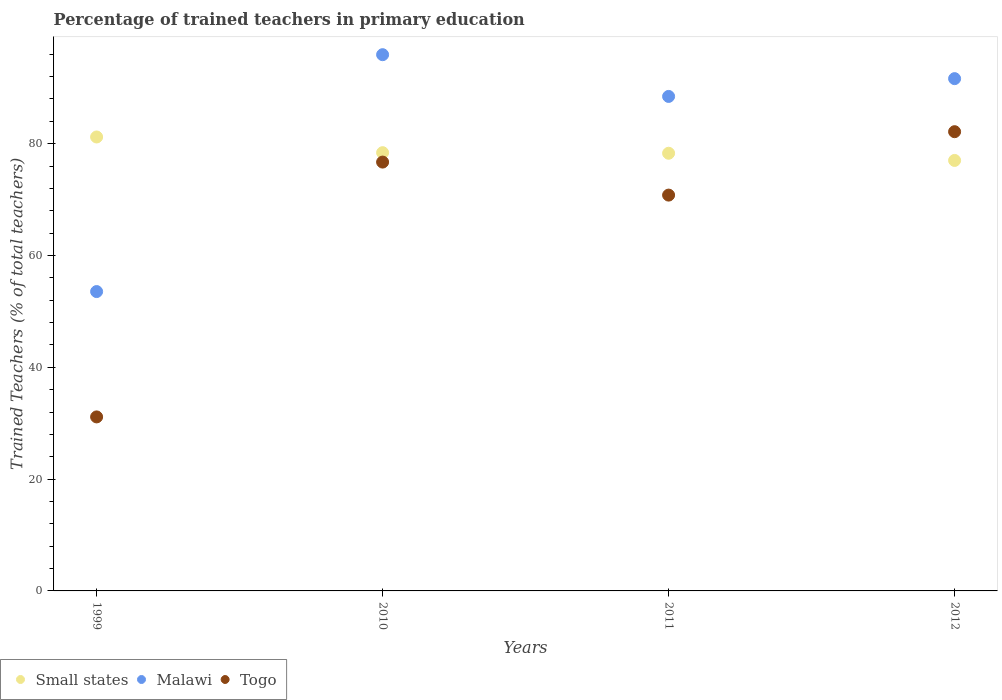Is the number of dotlines equal to the number of legend labels?
Offer a terse response. Yes. What is the percentage of trained teachers in Malawi in 2012?
Ensure brevity in your answer.  91.63. Across all years, what is the maximum percentage of trained teachers in Malawi?
Keep it short and to the point. 95.91. Across all years, what is the minimum percentage of trained teachers in Togo?
Your answer should be compact. 31.12. In which year was the percentage of trained teachers in Togo minimum?
Offer a terse response. 1999. What is the total percentage of trained teachers in Togo in the graph?
Offer a terse response. 260.76. What is the difference between the percentage of trained teachers in Malawi in 2011 and that in 2012?
Keep it short and to the point. -3.18. What is the difference between the percentage of trained teachers in Small states in 1999 and the percentage of trained teachers in Malawi in 2010?
Give a very brief answer. -14.72. What is the average percentage of trained teachers in Malawi per year?
Offer a terse response. 82.38. In the year 2012, what is the difference between the percentage of trained teachers in Small states and percentage of trained teachers in Togo?
Offer a terse response. -5.14. What is the ratio of the percentage of trained teachers in Small states in 1999 to that in 2010?
Your response must be concise. 1.04. What is the difference between the highest and the second highest percentage of trained teachers in Togo?
Offer a terse response. 5.44. What is the difference between the highest and the lowest percentage of trained teachers in Small states?
Provide a succinct answer. 4.2. In how many years, is the percentage of trained teachers in Small states greater than the average percentage of trained teachers in Small states taken over all years?
Make the answer very short. 1. Is the sum of the percentage of trained teachers in Malawi in 2010 and 2011 greater than the maximum percentage of trained teachers in Togo across all years?
Make the answer very short. Yes. Does the percentage of trained teachers in Togo monotonically increase over the years?
Offer a terse response. No. Is the percentage of trained teachers in Togo strictly greater than the percentage of trained teachers in Small states over the years?
Keep it short and to the point. No. How many years are there in the graph?
Offer a very short reply. 4. Does the graph contain any zero values?
Keep it short and to the point. No. How many legend labels are there?
Your answer should be very brief. 3. How are the legend labels stacked?
Keep it short and to the point. Horizontal. What is the title of the graph?
Ensure brevity in your answer.  Percentage of trained teachers in primary education. What is the label or title of the X-axis?
Keep it short and to the point. Years. What is the label or title of the Y-axis?
Your response must be concise. Trained Teachers (% of total teachers). What is the Trained Teachers (% of total teachers) in Small states in 1999?
Your answer should be compact. 81.19. What is the Trained Teachers (% of total teachers) in Malawi in 1999?
Ensure brevity in your answer.  53.54. What is the Trained Teachers (% of total teachers) of Togo in 1999?
Offer a very short reply. 31.12. What is the Trained Teachers (% of total teachers) in Small states in 2010?
Keep it short and to the point. 78.39. What is the Trained Teachers (% of total teachers) of Malawi in 2010?
Offer a terse response. 95.91. What is the Trained Teachers (% of total teachers) in Togo in 2010?
Make the answer very short. 76.7. What is the Trained Teachers (% of total teachers) of Small states in 2011?
Keep it short and to the point. 78.28. What is the Trained Teachers (% of total teachers) in Malawi in 2011?
Offer a very short reply. 88.45. What is the Trained Teachers (% of total teachers) of Togo in 2011?
Ensure brevity in your answer.  70.8. What is the Trained Teachers (% of total teachers) of Small states in 2012?
Offer a terse response. 77. What is the Trained Teachers (% of total teachers) in Malawi in 2012?
Provide a succinct answer. 91.63. What is the Trained Teachers (% of total teachers) of Togo in 2012?
Keep it short and to the point. 82.14. Across all years, what is the maximum Trained Teachers (% of total teachers) in Small states?
Your answer should be very brief. 81.19. Across all years, what is the maximum Trained Teachers (% of total teachers) in Malawi?
Make the answer very short. 95.91. Across all years, what is the maximum Trained Teachers (% of total teachers) of Togo?
Offer a very short reply. 82.14. Across all years, what is the minimum Trained Teachers (% of total teachers) of Small states?
Offer a very short reply. 77. Across all years, what is the minimum Trained Teachers (% of total teachers) in Malawi?
Provide a succinct answer. 53.54. Across all years, what is the minimum Trained Teachers (% of total teachers) of Togo?
Provide a short and direct response. 31.12. What is the total Trained Teachers (% of total teachers) in Small states in the graph?
Your answer should be compact. 314.86. What is the total Trained Teachers (% of total teachers) in Malawi in the graph?
Make the answer very short. 329.53. What is the total Trained Teachers (% of total teachers) in Togo in the graph?
Keep it short and to the point. 260.76. What is the difference between the Trained Teachers (% of total teachers) of Small states in 1999 and that in 2010?
Keep it short and to the point. 2.81. What is the difference between the Trained Teachers (% of total teachers) of Malawi in 1999 and that in 2010?
Keep it short and to the point. -42.37. What is the difference between the Trained Teachers (% of total teachers) of Togo in 1999 and that in 2010?
Your answer should be very brief. -45.58. What is the difference between the Trained Teachers (% of total teachers) in Small states in 1999 and that in 2011?
Provide a short and direct response. 2.91. What is the difference between the Trained Teachers (% of total teachers) of Malawi in 1999 and that in 2011?
Give a very brief answer. -34.9. What is the difference between the Trained Teachers (% of total teachers) of Togo in 1999 and that in 2011?
Make the answer very short. -39.67. What is the difference between the Trained Teachers (% of total teachers) in Small states in 1999 and that in 2012?
Keep it short and to the point. 4.2. What is the difference between the Trained Teachers (% of total teachers) of Malawi in 1999 and that in 2012?
Your response must be concise. -38.08. What is the difference between the Trained Teachers (% of total teachers) of Togo in 1999 and that in 2012?
Ensure brevity in your answer.  -51.01. What is the difference between the Trained Teachers (% of total teachers) of Small states in 2010 and that in 2011?
Your answer should be compact. 0.1. What is the difference between the Trained Teachers (% of total teachers) of Malawi in 2010 and that in 2011?
Ensure brevity in your answer.  7.47. What is the difference between the Trained Teachers (% of total teachers) in Togo in 2010 and that in 2011?
Provide a short and direct response. 5.91. What is the difference between the Trained Teachers (% of total teachers) of Small states in 2010 and that in 2012?
Make the answer very short. 1.39. What is the difference between the Trained Teachers (% of total teachers) in Malawi in 2010 and that in 2012?
Keep it short and to the point. 4.28. What is the difference between the Trained Teachers (% of total teachers) in Togo in 2010 and that in 2012?
Provide a short and direct response. -5.44. What is the difference between the Trained Teachers (% of total teachers) of Small states in 2011 and that in 2012?
Keep it short and to the point. 1.29. What is the difference between the Trained Teachers (% of total teachers) of Malawi in 2011 and that in 2012?
Ensure brevity in your answer.  -3.18. What is the difference between the Trained Teachers (% of total teachers) in Togo in 2011 and that in 2012?
Your answer should be very brief. -11.34. What is the difference between the Trained Teachers (% of total teachers) in Small states in 1999 and the Trained Teachers (% of total teachers) in Malawi in 2010?
Your answer should be compact. -14.72. What is the difference between the Trained Teachers (% of total teachers) in Small states in 1999 and the Trained Teachers (% of total teachers) in Togo in 2010?
Provide a short and direct response. 4.49. What is the difference between the Trained Teachers (% of total teachers) of Malawi in 1999 and the Trained Teachers (% of total teachers) of Togo in 2010?
Your answer should be compact. -23.16. What is the difference between the Trained Teachers (% of total teachers) of Small states in 1999 and the Trained Teachers (% of total teachers) of Malawi in 2011?
Keep it short and to the point. -7.25. What is the difference between the Trained Teachers (% of total teachers) of Small states in 1999 and the Trained Teachers (% of total teachers) of Togo in 2011?
Your answer should be very brief. 10.4. What is the difference between the Trained Teachers (% of total teachers) of Malawi in 1999 and the Trained Teachers (% of total teachers) of Togo in 2011?
Your response must be concise. -17.25. What is the difference between the Trained Teachers (% of total teachers) of Small states in 1999 and the Trained Teachers (% of total teachers) of Malawi in 2012?
Keep it short and to the point. -10.43. What is the difference between the Trained Teachers (% of total teachers) of Small states in 1999 and the Trained Teachers (% of total teachers) of Togo in 2012?
Offer a very short reply. -0.94. What is the difference between the Trained Teachers (% of total teachers) of Malawi in 1999 and the Trained Teachers (% of total teachers) of Togo in 2012?
Your answer should be compact. -28.6. What is the difference between the Trained Teachers (% of total teachers) in Small states in 2010 and the Trained Teachers (% of total teachers) in Malawi in 2011?
Keep it short and to the point. -10.06. What is the difference between the Trained Teachers (% of total teachers) of Small states in 2010 and the Trained Teachers (% of total teachers) of Togo in 2011?
Keep it short and to the point. 7.59. What is the difference between the Trained Teachers (% of total teachers) of Malawi in 2010 and the Trained Teachers (% of total teachers) of Togo in 2011?
Give a very brief answer. 25.12. What is the difference between the Trained Teachers (% of total teachers) in Small states in 2010 and the Trained Teachers (% of total teachers) in Malawi in 2012?
Make the answer very short. -13.24. What is the difference between the Trained Teachers (% of total teachers) of Small states in 2010 and the Trained Teachers (% of total teachers) of Togo in 2012?
Your answer should be very brief. -3.75. What is the difference between the Trained Teachers (% of total teachers) of Malawi in 2010 and the Trained Teachers (% of total teachers) of Togo in 2012?
Your answer should be very brief. 13.77. What is the difference between the Trained Teachers (% of total teachers) in Small states in 2011 and the Trained Teachers (% of total teachers) in Malawi in 2012?
Your answer should be compact. -13.34. What is the difference between the Trained Teachers (% of total teachers) in Small states in 2011 and the Trained Teachers (% of total teachers) in Togo in 2012?
Keep it short and to the point. -3.86. What is the difference between the Trained Teachers (% of total teachers) in Malawi in 2011 and the Trained Teachers (% of total teachers) in Togo in 2012?
Your response must be concise. 6.31. What is the average Trained Teachers (% of total teachers) of Small states per year?
Keep it short and to the point. 78.72. What is the average Trained Teachers (% of total teachers) of Malawi per year?
Your response must be concise. 82.38. What is the average Trained Teachers (% of total teachers) in Togo per year?
Give a very brief answer. 65.19. In the year 1999, what is the difference between the Trained Teachers (% of total teachers) in Small states and Trained Teachers (% of total teachers) in Malawi?
Your answer should be compact. 27.65. In the year 1999, what is the difference between the Trained Teachers (% of total teachers) in Small states and Trained Teachers (% of total teachers) in Togo?
Provide a short and direct response. 50.07. In the year 1999, what is the difference between the Trained Teachers (% of total teachers) of Malawi and Trained Teachers (% of total teachers) of Togo?
Ensure brevity in your answer.  22.42. In the year 2010, what is the difference between the Trained Teachers (% of total teachers) of Small states and Trained Teachers (% of total teachers) of Malawi?
Your answer should be compact. -17.53. In the year 2010, what is the difference between the Trained Teachers (% of total teachers) of Small states and Trained Teachers (% of total teachers) of Togo?
Offer a very short reply. 1.68. In the year 2010, what is the difference between the Trained Teachers (% of total teachers) of Malawi and Trained Teachers (% of total teachers) of Togo?
Provide a short and direct response. 19.21. In the year 2011, what is the difference between the Trained Teachers (% of total teachers) of Small states and Trained Teachers (% of total teachers) of Malawi?
Offer a very short reply. -10.16. In the year 2011, what is the difference between the Trained Teachers (% of total teachers) of Small states and Trained Teachers (% of total teachers) of Togo?
Offer a terse response. 7.49. In the year 2011, what is the difference between the Trained Teachers (% of total teachers) of Malawi and Trained Teachers (% of total teachers) of Togo?
Provide a succinct answer. 17.65. In the year 2012, what is the difference between the Trained Teachers (% of total teachers) of Small states and Trained Teachers (% of total teachers) of Malawi?
Ensure brevity in your answer.  -14.63. In the year 2012, what is the difference between the Trained Teachers (% of total teachers) of Small states and Trained Teachers (% of total teachers) of Togo?
Keep it short and to the point. -5.14. In the year 2012, what is the difference between the Trained Teachers (% of total teachers) in Malawi and Trained Teachers (% of total teachers) in Togo?
Offer a very short reply. 9.49. What is the ratio of the Trained Teachers (% of total teachers) in Small states in 1999 to that in 2010?
Offer a terse response. 1.04. What is the ratio of the Trained Teachers (% of total teachers) of Malawi in 1999 to that in 2010?
Ensure brevity in your answer.  0.56. What is the ratio of the Trained Teachers (% of total teachers) of Togo in 1999 to that in 2010?
Offer a terse response. 0.41. What is the ratio of the Trained Teachers (% of total teachers) in Small states in 1999 to that in 2011?
Offer a very short reply. 1.04. What is the ratio of the Trained Teachers (% of total teachers) of Malawi in 1999 to that in 2011?
Your answer should be very brief. 0.61. What is the ratio of the Trained Teachers (% of total teachers) in Togo in 1999 to that in 2011?
Your answer should be compact. 0.44. What is the ratio of the Trained Teachers (% of total teachers) in Small states in 1999 to that in 2012?
Your answer should be very brief. 1.05. What is the ratio of the Trained Teachers (% of total teachers) in Malawi in 1999 to that in 2012?
Your answer should be compact. 0.58. What is the ratio of the Trained Teachers (% of total teachers) of Togo in 1999 to that in 2012?
Your answer should be compact. 0.38. What is the ratio of the Trained Teachers (% of total teachers) of Malawi in 2010 to that in 2011?
Provide a short and direct response. 1.08. What is the ratio of the Trained Teachers (% of total teachers) in Togo in 2010 to that in 2011?
Keep it short and to the point. 1.08. What is the ratio of the Trained Teachers (% of total teachers) of Malawi in 2010 to that in 2012?
Keep it short and to the point. 1.05. What is the ratio of the Trained Teachers (% of total teachers) in Togo in 2010 to that in 2012?
Ensure brevity in your answer.  0.93. What is the ratio of the Trained Teachers (% of total teachers) in Small states in 2011 to that in 2012?
Ensure brevity in your answer.  1.02. What is the ratio of the Trained Teachers (% of total teachers) in Malawi in 2011 to that in 2012?
Your answer should be very brief. 0.97. What is the ratio of the Trained Teachers (% of total teachers) of Togo in 2011 to that in 2012?
Offer a very short reply. 0.86. What is the difference between the highest and the second highest Trained Teachers (% of total teachers) of Small states?
Your response must be concise. 2.81. What is the difference between the highest and the second highest Trained Teachers (% of total teachers) in Malawi?
Your response must be concise. 4.28. What is the difference between the highest and the second highest Trained Teachers (% of total teachers) in Togo?
Provide a succinct answer. 5.44. What is the difference between the highest and the lowest Trained Teachers (% of total teachers) in Small states?
Your answer should be compact. 4.2. What is the difference between the highest and the lowest Trained Teachers (% of total teachers) of Malawi?
Offer a terse response. 42.37. What is the difference between the highest and the lowest Trained Teachers (% of total teachers) in Togo?
Your response must be concise. 51.01. 